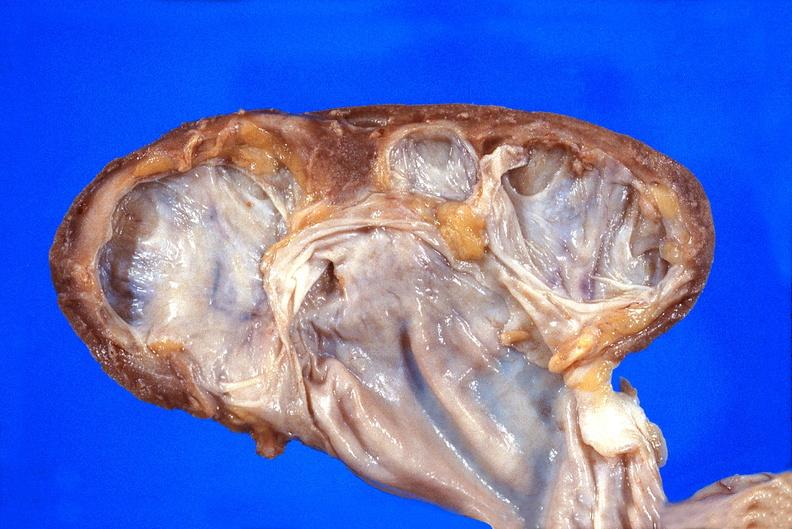does this image show kidney, hydronephrosis?
Answer the question using a single word or phrase. Yes 